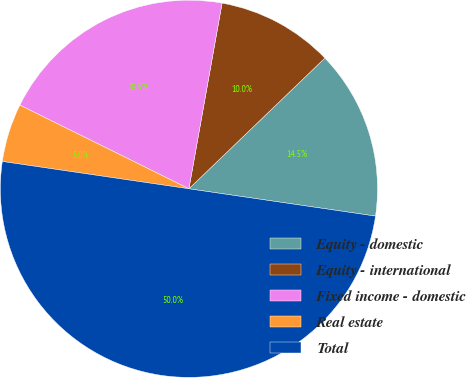<chart> <loc_0><loc_0><loc_500><loc_500><pie_chart><fcel>Equity - domestic<fcel>Equity - international<fcel>Fixed income - domestic<fcel>Real estate<fcel>Total<nl><fcel>14.5%<fcel>10.0%<fcel>20.5%<fcel>5.0%<fcel>50.0%<nl></chart> 